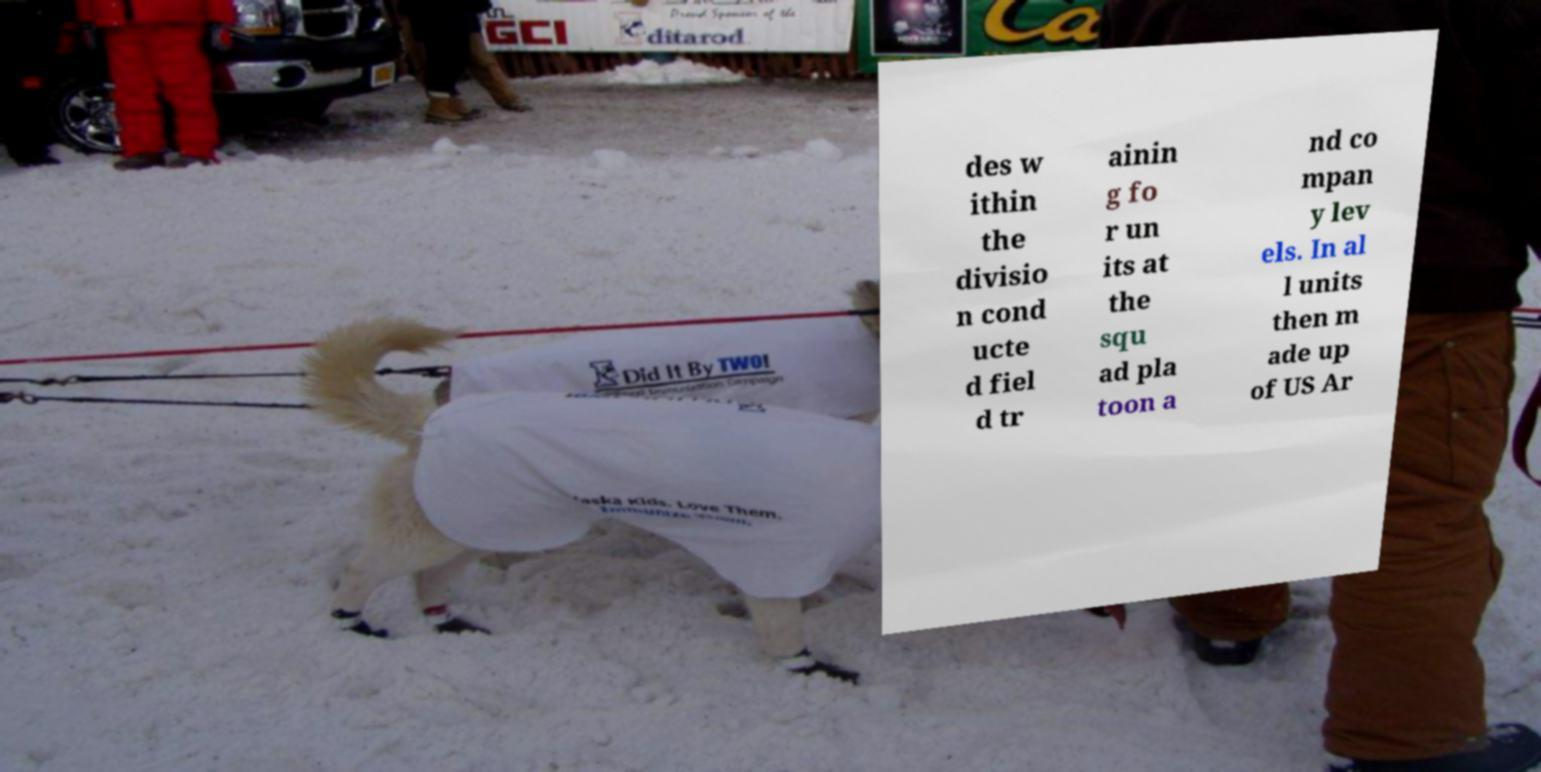Please identify and transcribe the text found in this image. des w ithin the divisio n cond ucte d fiel d tr ainin g fo r un its at the squ ad pla toon a nd co mpan y lev els. In al l units then m ade up of US Ar 